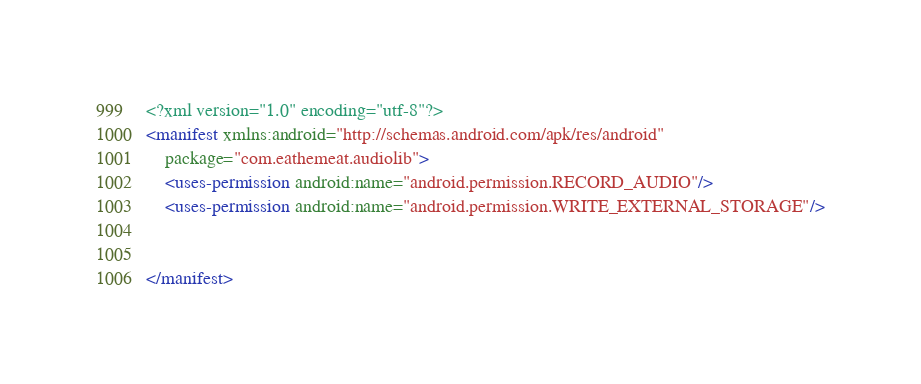<code> <loc_0><loc_0><loc_500><loc_500><_XML_><?xml version="1.0" encoding="utf-8"?>
<manifest xmlns:android="http://schemas.android.com/apk/res/android"
    package="com.eathemeat.audiolib">
    <uses-permission android:name="android.permission.RECORD_AUDIO"/>
    <uses-permission android:name="android.permission.WRITE_EXTERNAL_STORAGE"/>


</manifest></code> 